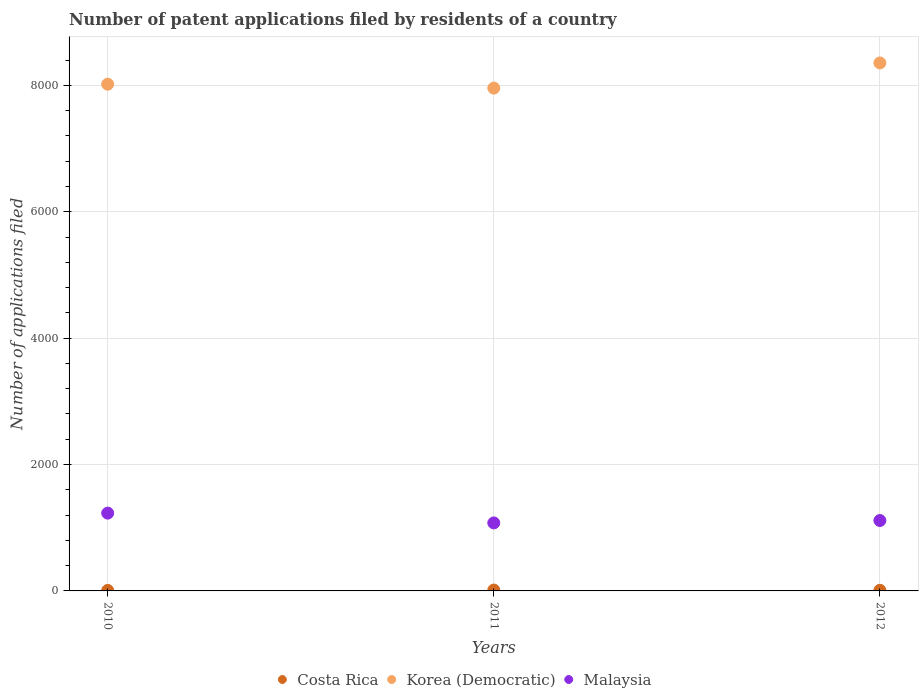What is the number of applications filed in Malaysia in 2012?
Give a very brief answer. 1114. Across all years, what is the maximum number of applications filed in Malaysia?
Provide a succinct answer. 1231. Across all years, what is the minimum number of applications filed in Korea (Democratic)?
Offer a terse response. 7956. In which year was the number of applications filed in Malaysia maximum?
Ensure brevity in your answer.  2010. In which year was the number of applications filed in Korea (Democratic) minimum?
Provide a succinct answer. 2011. What is the total number of applications filed in Malaysia in the graph?
Your answer should be compact. 3421. What is the difference between the number of applications filed in Malaysia in 2011 and that in 2012?
Make the answer very short. -38. What is the difference between the number of applications filed in Korea (Democratic) in 2010 and the number of applications filed in Malaysia in 2012?
Keep it short and to the point. 6904. What is the average number of applications filed in Costa Rica per year?
Offer a very short reply. 10.67. In the year 2010, what is the difference between the number of applications filed in Costa Rica and number of applications filed in Malaysia?
Your answer should be very brief. -1223. In how many years, is the number of applications filed in Korea (Democratic) greater than 6400?
Make the answer very short. 3. What is the ratio of the number of applications filed in Korea (Democratic) in 2010 to that in 2011?
Keep it short and to the point. 1.01. Is the number of applications filed in Costa Rica in 2010 less than that in 2012?
Your answer should be very brief. Yes. Is the difference between the number of applications filed in Costa Rica in 2011 and 2012 greater than the difference between the number of applications filed in Malaysia in 2011 and 2012?
Provide a succinct answer. Yes. What is the difference between the highest and the lowest number of applications filed in Malaysia?
Give a very brief answer. 155. In how many years, is the number of applications filed in Costa Rica greater than the average number of applications filed in Costa Rica taken over all years?
Keep it short and to the point. 1. Is it the case that in every year, the sum of the number of applications filed in Malaysia and number of applications filed in Costa Rica  is greater than the number of applications filed in Korea (Democratic)?
Your response must be concise. No. Does the number of applications filed in Costa Rica monotonically increase over the years?
Offer a terse response. No. Is the number of applications filed in Malaysia strictly less than the number of applications filed in Costa Rica over the years?
Keep it short and to the point. No. How many years are there in the graph?
Ensure brevity in your answer.  3. Are the values on the major ticks of Y-axis written in scientific E-notation?
Offer a terse response. No. Does the graph contain any zero values?
Provide a succinct answer. No. Does the graph contain grids?
Provide a succinct answer. Yes. Where does the legend appear in the graph?
Make the answer very short. Bottom center. What is the title of the graph?
Offer a terse response. Number of patent applications filed by residents of a country. What is the label or title of the Y-axis?
Ensure brevity in your answer.  Number of applications filed. What is the Number of applications filed of Korea (Democratic) in 2010?
Make the answer very short. 8018. What is the Number of applications filed in Malaysia in 2010?
Give a very brief answer. 1231. What is the Number of applications filed in Korea (Democratic) in 2011?
Your answer should be compact. 7956. What is the Number of applications filed of Malaysia in 2011?
Offer a terse response. 1076. What is the Number of applications filed of Costa Rica in 2012?
Give a very brief answer. 10. What is the Number of applications filed in Korea (Democratic) in 2012?
Give a very brief answer. 8354. What is the Number of applications filed of Malaysia in 2012?
Your answer should be compact. 1114. Across all years, what is the maximum Number of applications filed in Korea (Democratic)?
Make the answer very short. 8354. Across all years, what is the maximum Number of applications filed in Malaysia?
Make the answer very short. 1231. Across all years, what is the minimum Number of applications filed of Costa Rica?
Your response must be concise. 8. Across all years, what is the minimum Number of applications filed in Korea (Democratic)?
Ensure brevity in your answer.  7956. Across all years, what is the minimum Number of applications filed of Malaysia?
Your answer should be very brief. 1076. What is the total Number of applications filed in Korea (Democratic) in the graph?
Provide a succinct answer. 2.43e+04. What is the total Number of applications filed of Malaysia in the graph?
Your answer should be compact. 3421. What is the difference between the Number of applications filed of Korea (Democratic) in 2010 and that in 2011?
Give a very brief answer. 62. What is the difference between the Number of applications filed in Malaysia in 2010 and that in 2011?
Offer a terse response. 155. What is the difference between the Number of applications filed of Costa Rica in 2010 and that in 2012?
Your response must be concise. -2. What is the difference between the Number of applications filed of Korea (Democratic) in 2010 and that in 2012?
Your answer should be very brief. -336. What is the difference between the Number of applications filed of Malaysia in 2010 and that in 2012?
Your answer should be very brief. 117. What is the difference between the Number of applications filed of Korea (Democratic) in 2011 and that in 2012?
Offer a very short reply. -398. What is the difference between the Number of applications filed of Malaysia in 2011 and that in 2012?
Your answer should be very brief. -38. What is the difference between the Number of applications filed in Costa Rica in 2010 and the Number of applications filed in Korea (Democratic) in 2011?
Make the answer very short. -7948. What is the difference between the Number of applications filed in Costa Rica in 2010 and the Number of applications filed in Malaysia in 2011?
Provide a short and direct response. -1068. What is the difference between the Number of applications filed of Korea (Democratic) in 2010 and the Number of applications filed of Malaysia in 2011?
Ensure brevity in your answer.  6942. What is the difference between the Number of applications filed in Costa Rica in 2010 and the Number of applications filed in Korea (Democratic) in 2012?
Your answer should be very brief. -8346. What is the difference between the Number of applications filed in Costa Rica in 2010 and the Number of applications filed in Malaysia in 2012?
Offer a very short reply. -1106. What is the difference between the Number of applications filed of Korea (Democratic) in 2010 and the Number of applications filed of Malaysia in 2012?
Offer a terse response. 6904. What is the difference between the Number of applications filed in Costa Rica in 2011 and the Number of applications filed in Korea (Democratic) in 2012?
Keep it short and to the point. -8340. What is the difference between the Number of applications filed in Costa Rica in 2011 and the Number of applications filed in Malaysia in 2012?
Offer a terse response. -1100. What is the difference between the Number of applications filed in Korea (Democratic) in 2011 and the Number of applications filed in Malaysia in 2012?
Your answer should be compact. 6842. What is the average Number of applications filed of Costa Rica per year?
Give a very brief answer. 10.67. What is the average Number of applications filed in Korea (Democratic) per year?
Your answer should be very brief. 8109.33. What is the average Number of applications filed in Malaysia per year?
Your answer should be very brief. 1140.33. In the year 2010, what is the difference between the Number of applications filed of Costa Rica and Number of applications filed of Korea (Democratic)?
Your answer should be compact. -8010. In the year 2010, what is the difference between the Number of applications filed in Costa Rica and Number of applications filed in Malaysia?
Offer a terse response. -1223. In the year 2010, what is the difference between the Number of applications filed in Korea (Democratic) and Number of applications filed in Malaysia?
Make the answer very short. 6787. In the year 2011, what is the difference between the Number of applications filed of Costa Rica and Number of applications filed of Korea (Democratic)?
Provide a short and direct response. -7942. In the year 2011, what is the difference between the Number of applications filed in Costa Rica and Number of applications filed in Malaysia?
Your response must be concise. -1062. In the year 2011, what is the difference between the Number of applications filed in Korea (Democratic) and Number of applications filed in Malaysia?
Your answer should be very brief. 6880. In the year 2012, what is the difference between the Number of applications filed of Costa Rica and Number of applications filed of Korea (Democratic)?
Offer a very short reply. -8344. In the year 2012, what is the difference between the Number of applications filed of Costa Rica and Number of applications filed of Malaysia?
Your answer should be compact. -1104. In the year 2012, what is the difference between the Number of applications filed of Korea (Democratic) and Number of applications filed of Malaysia?
Your response must be concise. 7240. What is the ratio of the Number of applications filed of Costa Rica in 2010 to that in 2011?
Your response must be concise. 0.57. What is the ratio of the Number of applications filed of Korea (Democratic) in 2010 to that in 2011?
Ensure brevity in your answer.  1.01. What is the ratio of the Number of applications filed in Malaysia in 2010 to that in 2011?
Provide a short and direct response. 1.14. What is the ratio of the Number of applications filed in Costa Rica in 2010 to that in 2012?
Give a very brief answer. 0.8. What is the ratio of the Number of applications filed in Korea (Democratic) in 2010 to that in 2012?
Your answer should be very brief. 0.96. What is the ratio of the Number of applications filed in Malaysia in 2010 to that in 2012?
Offer a very short reply. 1.1. What is the ratio of the Number of applications filed in Korea (Democratic) in 2011 to that in 2012?
Ensure brevity in your answer.  0.95. What is the ratio of the Number of applications filed of Malaysia in 2011 to that in 2012?
Offer a very short reply. 0.97. What is the difference between the highest and the second highest Number of applications filed of Costa Rica?
Provide a succinct answer. 4. What is the difference between the highest and the second highest Number of applications filed of Korea (Democratic)?
Your answer should be compact. 336. What is the difference between the highest and the second highest Number of applications filed of Malaysia?
Give a very brief answer. 117. What is the difference between the highest and the lowest Number of applications filed of Costa Rica?
Ensure brevity in your answer.  6. What is the difference between the highest and the lowest Number of applications filed in Korea (Democratic)?
Your answer should be very brief. 398. What is the difference between the highest and the lowest Number of applications filed of Malaysia?
Your answer should be compact. 155. 